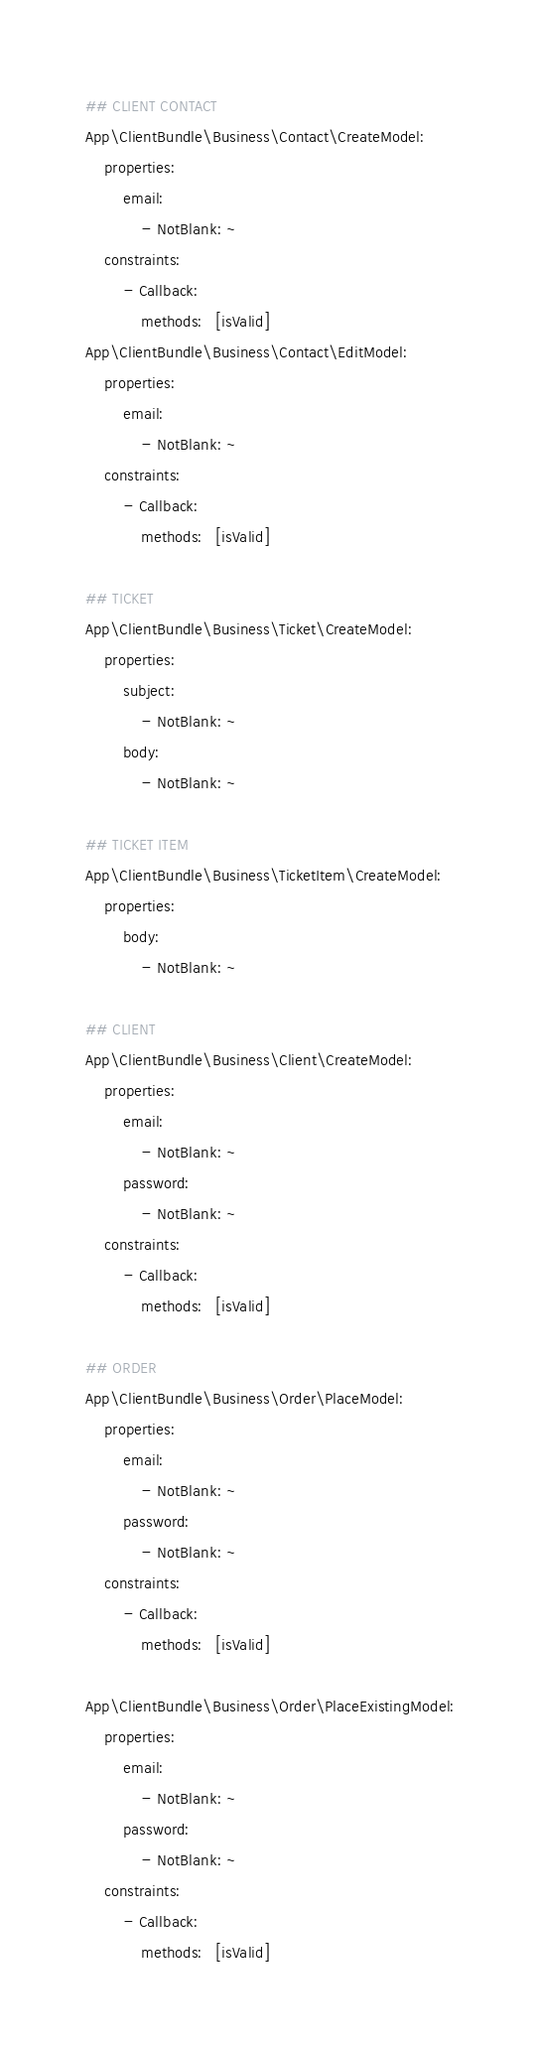<code> <loc_0><loc_0><loc_500><loc_500><_YAML_>
## CLIENT CONTACT
App\ClientBundle\Business\Contact\CreateModel:
    properties:
        email:
            - NotBlank: ~
    constraints:
        - Callback:
            methods:   [isValid]
App\ClientBundle\Business\Contact\EditModel:
    properties:
        email:
            - NotBlank: ~
    constraints:
        - Callback:
            methods:   [isValid]

## TICKET
App\ClientBundle\Business\Ticket\CreateModel:
    properties:
        subject:
            - NotBlank: ~
        body:
            - NotBlank: ~

## TICKET ITEM
App\ClientBundle\Business\TicketItem\CreateModel:
    properties:
        body:
            - NotBlank: ~

## CLIENT
App\ClientBundle\Business\Client\CreateModel:
    properties:
        email:
            - NotBlank: ~
        password:
            - NotBlank: ~
    constraints:
        - Callback:
            methods:   [isValid]

## ORDER
App\ClientBundle\Business\Order\PlaceModel:
    properties:
        email:
            - NotBlank: ~
        password:
            - NotBlank: ~
    constraints:
        - Callback:
            methods:   [isValid]

App\ClientBundle\Business\Order\PlaceExistingModel:
    properties:
        email:
            - NotBlank: ~
        password:
            - NotBlank: ~
    constraints:
        - Callback:
            methods:   [isValid]
</code> 